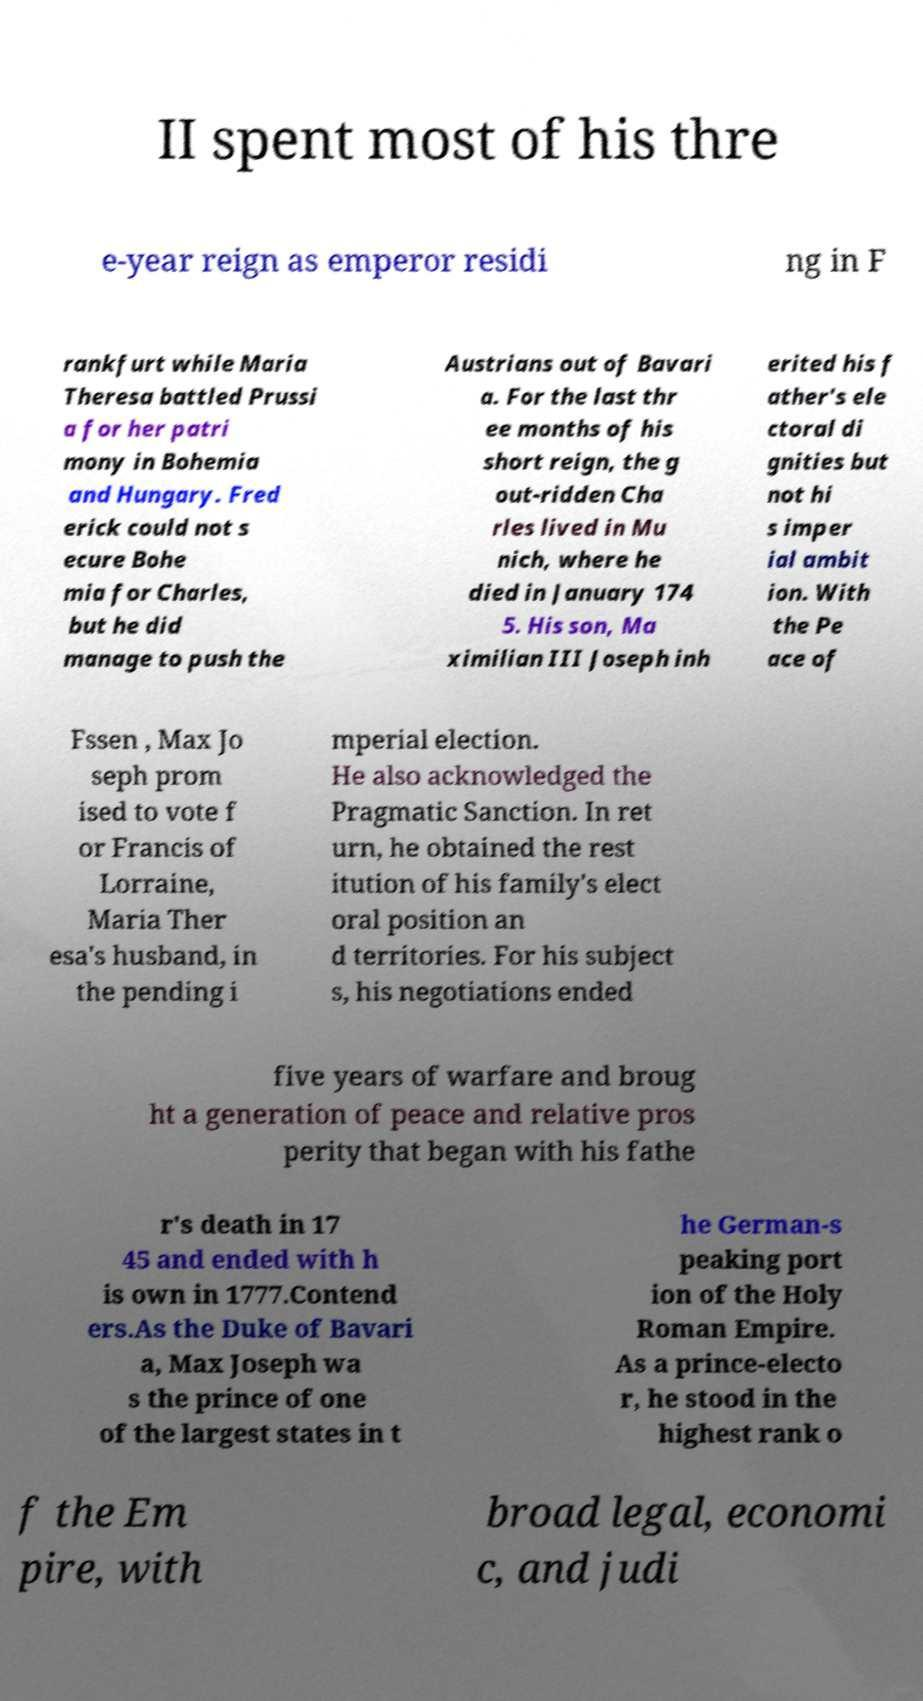There's text embedded in this image that I need extracted. Can you transcribe it verbatim? II spent most of his thre e-year reign as emperor residi ng in F rankfurt while Maria Theresa battled Prussi a for her patri mony in Bohemia and Hungary. Fred erick could not s ecure Bohe mia for Charles, but he did manage to push the Austrians out of Bavari a. For the last thr ee months of his short reign, the g out-ridden Cha rles lived in Mu nich, where he died in January 174 5. His son, Ma ximilian III Joseph inh erited his f ather's ele ctoral di gnities but not hi s imper ial ambit ion. With the Pe ace of Fssen , Max Jo seph prom ised to vote f or Francis of Lorraine, Maria Ther esa's husband, in the pending i mperial election. He also acknowledged the Pragmatic Sanction. In ret urn, he obtained the rest itution of his family's elect oral position an d territories. For his subject s, his negotiations ended five years of warfare and broug ht a generation of peace and relative pros perity that began with his fathe r's death in 17 45 and ended with h is own in 1777.Contend ers.As the Duke of Bavari a, Max Joseph wa s the prince of one of the largest states in t he German-s peaking port ion of the Holy Roman Empire. As a prince-electo r, he stood in the highest rank o f the Em pire, with broad legal, economi c, and judi 